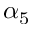<formula> <loc_0><loc_0><loc_500><loc_500>\alpha _ { 5 }</formula> 